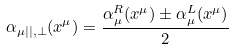Convert formula to latex. <formula><loc_0><loc_0><loc_500><loc_500>\alpha _ { \mu | | , \perp } ( x ^ { \mu } ) = \frac { \alpha ^ { R } _ { \mu } ( x ^ { \mu } ) \pm \alpha ^ { L } _ { \mu } ( x ^ { \mu } ) } { 2 } \,</formula> 